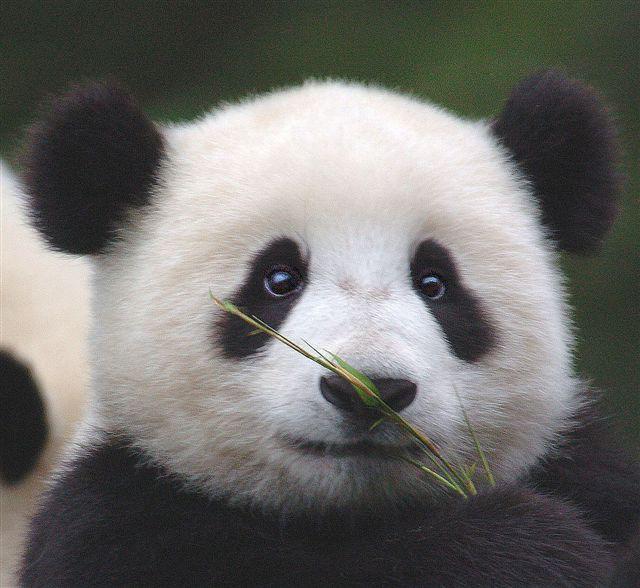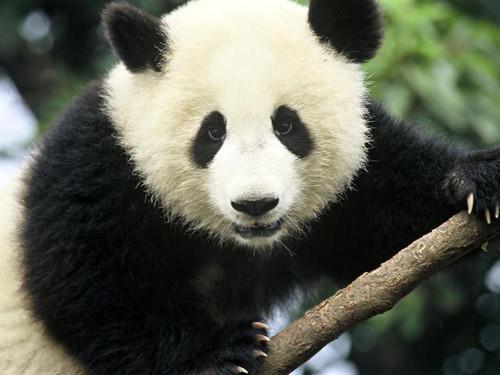The first image is the image on the left, the second image is the image on the right. Examine the images to the left and right. Is the description "There are a total of three panda bears in these images." accurate? Answer yes or no. No. The first image is the image on the left, the second image is the image on the right. Assess this claim about the two images: "There are three panda bears". Correct or not? Answer yes or no. No. 